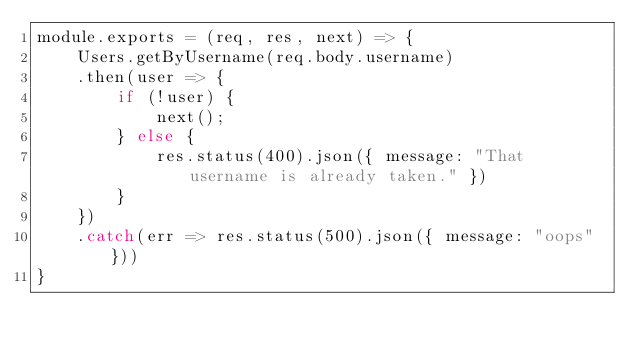<code> <loc_0><loc_0><loc_500><loc_500><_JavaScript_>module.exports = (req, res, next) => {
    Users.getByUsername(req.body.username)
    .then(user => {
        if (!user) {
            next();
        } else {
            res.status(400).json({ message: "That username is already taken." })
        }
    })
    .catch(err => res.status(500).json({ message: "oops"}))
}</code> 